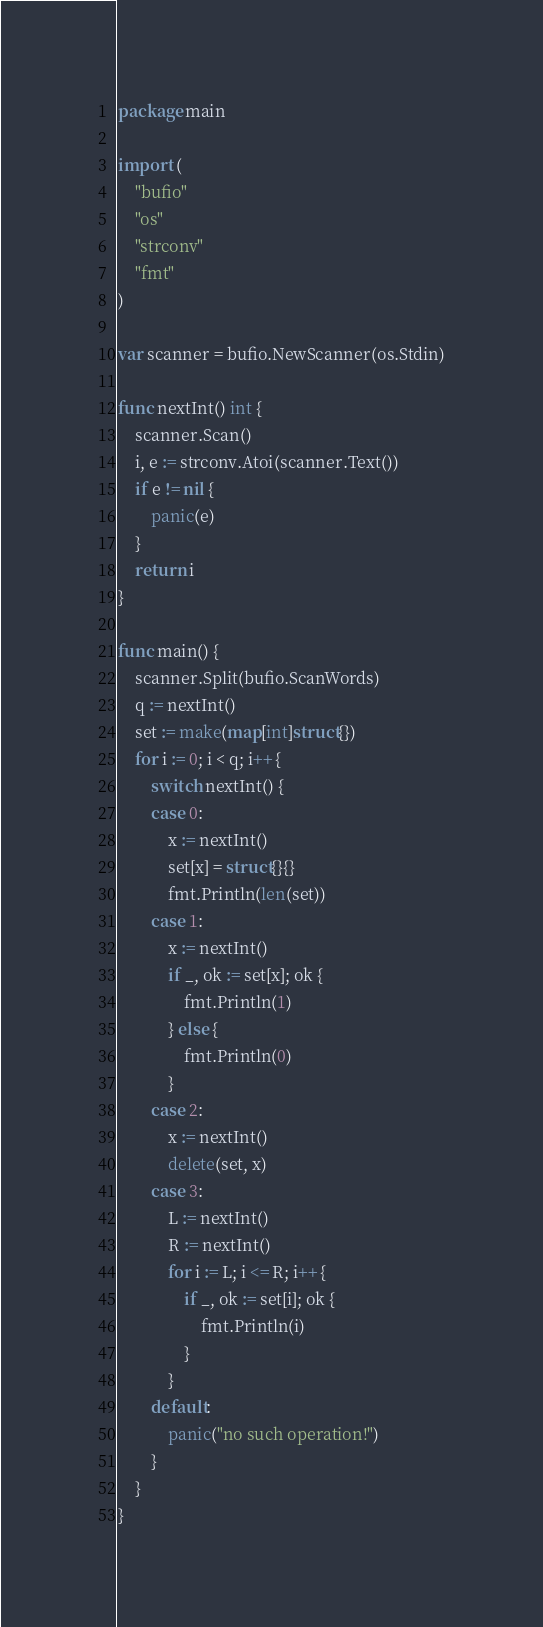Convert code to text. <code><loc_0><loc_0><loc_500><loc_500><_Go_>package main

import (
	"bufio"
	"os"
	"strconv"
	"fmt"
)

var scanner = bufio.NewScanner(os.Stdin)

func nextInt() int {
	scanner.Scan()
	i, e := strconv.Atoi(scanner.Text())
	if e != nil {
		panic(e)
	}
	return i
}

func main() {
	scanner.Split(bufio.ScanWords)
	q := nextInt()
	set := make(map[int]struct{})
	for i := 0; i < q; i++ {
		switch nextInt() {
		case 0:
			x := nextInt()
			set[x] = struct{}{}
			fmt.Println(len(set))
		case 1:
			x := nextInt()
			if _, ok := set[x]; ok {
				fmt.Println(1)
			} else {
				fmt.Println(0)
			}
		case 2:
			x := nextInt()
			delete(set, x)
		case 3:
			L := nextInt()
			R := nextInt()
			for i := L; i <= R; i++ {
				if _, ok := set[i]; ok {
					fmt.Println(i)
				}
			}
		default:
			panic("no such operation!")
		}
	}
}
</code> 